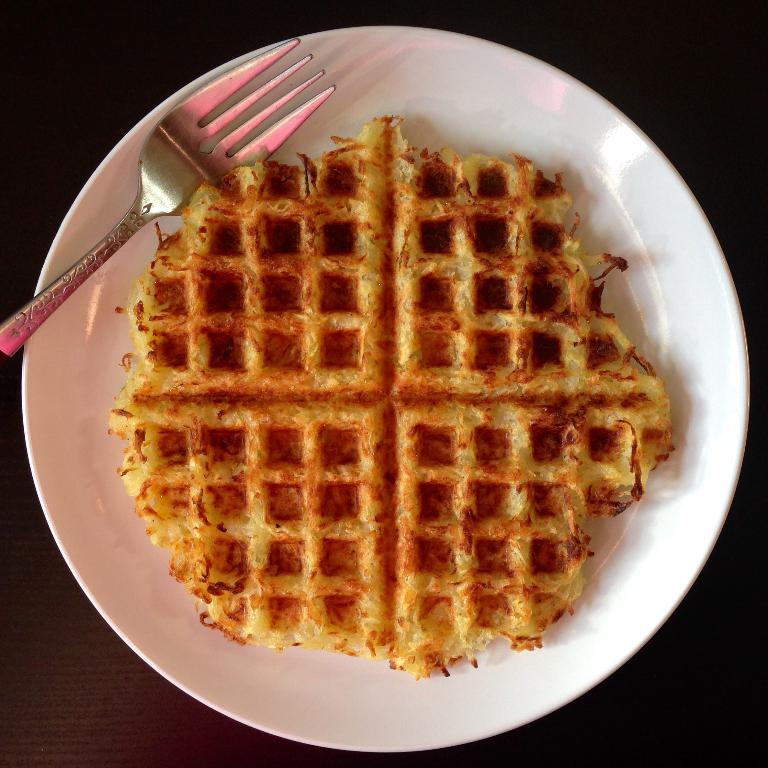What is located in the center of the image? There is a plate in the center of the image. What is on the plate? There is food on the plate. What utensil is present in the image? There is a spoon in the image. What type of furniture is visible in the image? There is a wooden table in the image. What type of toys can be seen on the plate in the image? There are no toys present on the plate in the image; it contains food. 